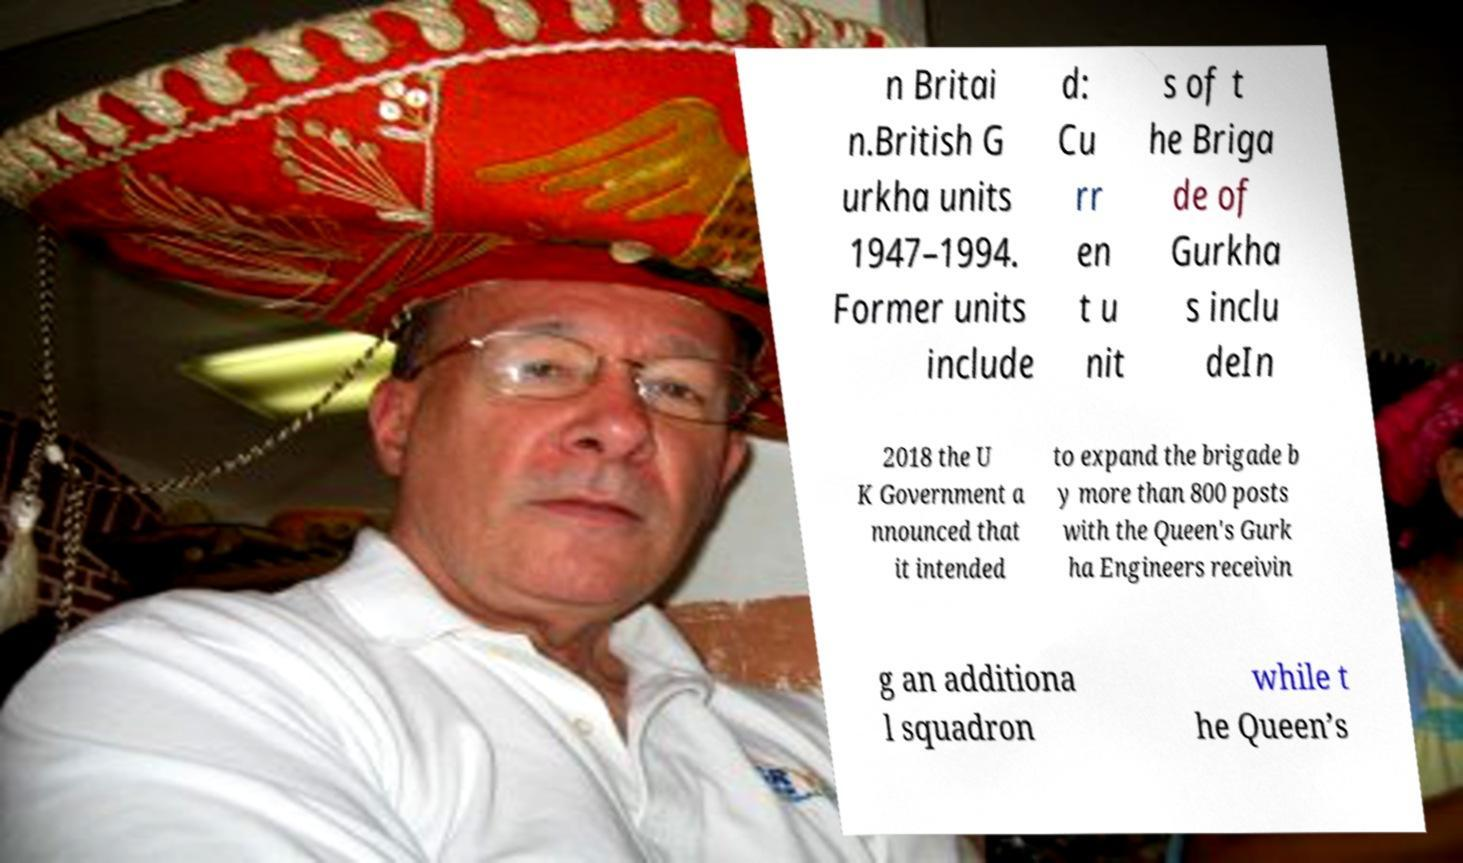Please identify and transcribe the text found in this image. n Britai n.British G urkha units 1947–1994. Former units include d: Cu rr en t u nit s of t he Briga de of Gurkha s inclu deIn 2018 the U K Government a nnounced that it intended to expand the brigade b y more than 800 posts with the Queen's Gurk ha Engineers receivin g an additiona l squadron while t he Queen’s 